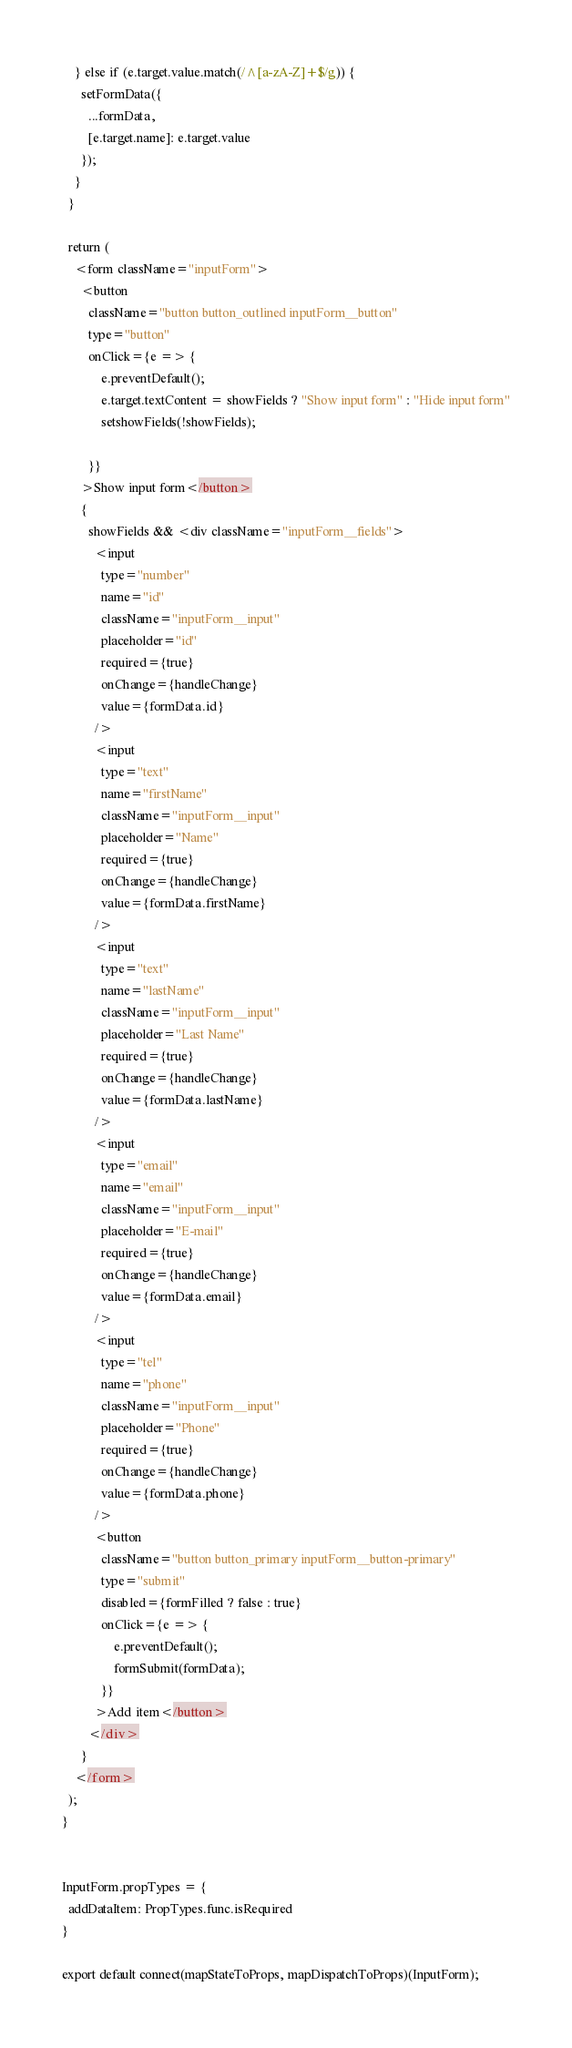Convert code to text. <code><loc_0><loc_0><loc_500><loc_500><_JavaScript_>    } else if (e.target.value.match(/^[a-zA-Z]+$/g)) {
      setFormData({
        ...formData,
        [e.target.name]: e.target.value
      });
    }
  }

  return (
    <form className="inputForm">
      <button
        className="button button_outlined inputForm__button"
        type="button"
        onClick={e => {
            e.preventDefault();
            e.target.textContent = showFields ? "Show input form" : "Hide input form"
            setshowFields(!showFields);

        }}
      >Show input form</button>
      {
        showFields && <div className="inputForm__fields">
          <input 
            type="number"
            name="id"
            className="inputForm__input"
            placeholder="id"
            required={true}
            onChange={handleChange}
            value={formData.id}
          />
          <input 
            type="text"
            name="firstName"
            className="inputForm__input"
            placeholder="Name"
            required={true}
            onChange={handleChange}
            value={formData.firstName}
          />
          <input 
            type="text"
            name="lastName"
            className="inputForm__input"
            placeholder="Last Name"
            required={true}
            onChange={handleChange}
            value={formData.lastName}
          />
          <input 
            type="email"
            name="email"
            className="inputForm__input"
            placeholder="E-mail"
            required={true}
            onChange={handleChange}
            value={formData.email}
          />
          <input 
            type="tel"
            name="phone"
            className="inputForm__input"
            placeholder="Phone"
            required={true}
            onChange={handleChange}
            value={formData.phone}
          />
          <button
            className="button button_primary inputForm__button-primary"
            type="submit"
            disabled={formFilled ? false : true}
            onClick={e => {
                e.preventDefault();
                formSubmit(formData);
            }}
          >Add item</button>
        </div>
      }
    </form>
  );
}


InputForm.propTypes = {
  addDataItem: PropTypes.func.isRequired
}

export default connect(mapStateToProps, mapDispatchToProps)(InputForm);</code> 